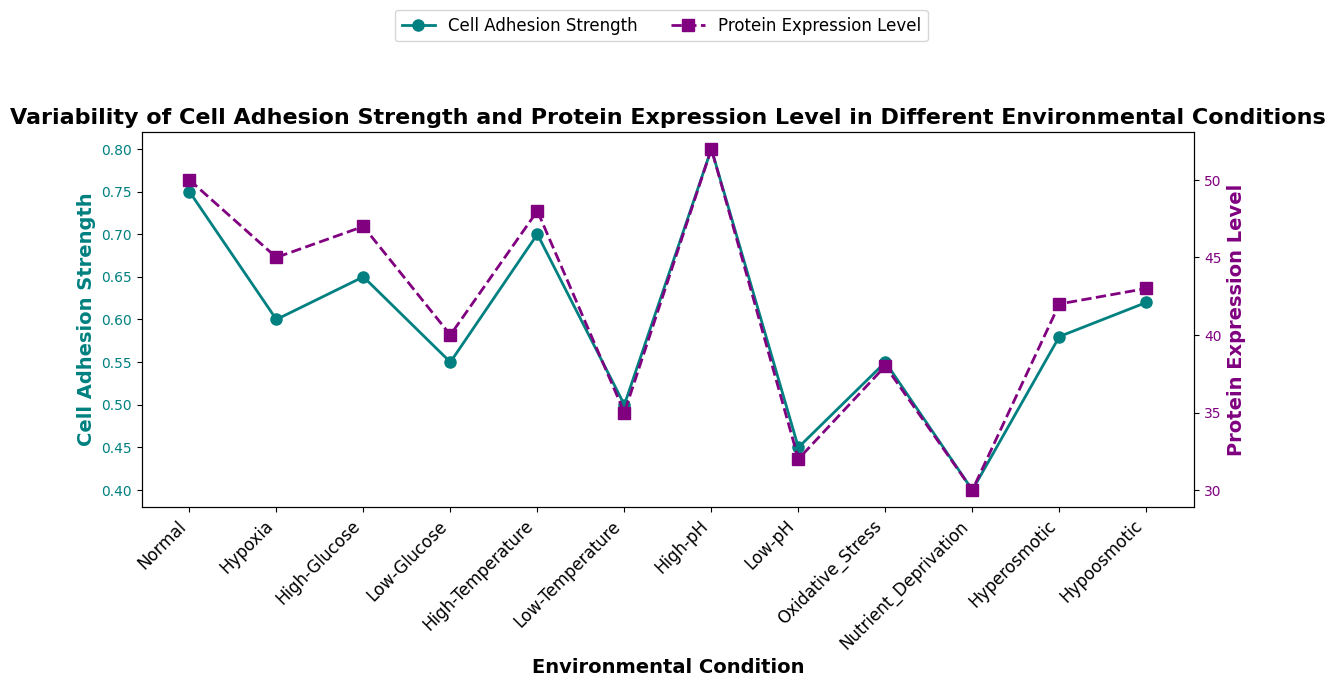What environmental condition shows the highest cell adhesion strength? By checking the plot, we can see that the highest point on the cell adhesion strength curve corresponds to the "High-pH" condition.
Answer: High-pH Which environmental condition has the lowest protein expression level? The graph shows the lowest point on the protein expression level curve, which corresponds to the "Nutrient Deprivation" condition.
Answer: Nutrient Deprivation Is there any condition where both cell adhesion strength and protein expression level are above their respective average values? First, calculate the average cell adhesion strength (sum all values and divide by the number of conditions: (0.75+0.60+0.65+0.55+0.70+0.50+0.80+0.45+0.55+0.40+0.58+0.62)/12 = 0.607) and protein expression level (sum all values and divide by the number of conditions: (50+45+47+40+48+35+52+32+38+30+42+43)/12 = 41.42). Then, find conditions where both values are above these averages. Only "High-pH" meets this criterion.
Answer: High-pH How does cell adhesion strength change under hypoosmotic vs. hyperosmotic conditions? Check the plot for the "Hypoosmotic" and "Hyperosmotic" conditions. Cell adhesion strength for "Hypoosmotic" is 0.62 and for "Hyperosmotic" is 0.58. Cell adhesion strength is higher under hypoosmotic conditions.
Answer: Higher under hypoosmotic What is the difference in cell adhesion strength between normal and nutrient deprivation conditions? Find the cell adhesion strength for "Normal" (0.75) and "Nutrient Deprivation" (0.40). Subtract the value for "Nutrient Deprivation" from the value for "Normal": 0.75 - 0.40 = 0.35.
Answer: 0.35 Does a higher protein expression level always correspond to a higher cell adhesion strength? Check the figure to match high protein expression level points with their respective cell adhesion strengths. For example, "Normal" has high values for both, but "Low-pH" with a low protein expression level of 32 has a low cell adhesion strength of 0.45, demonstrating it is not always correlated.
Answer: No On average, how do cell adhesion strengths under temperature deviations (high and low) compare with the rest of the conditions? Average cell adhesion strength for high and low temperature is (0.70 + 0.50)/2 = 0.60. Average for rest of the conditions is (0.75+0.60+0.65+0.55+0.80+0.45+0.55+0.40+0.58+0.62)/10 = 0.605. Compare these averages: 0.60 vs 0.605. The average is slightly lower for temperature deviations than other conditions.
Answer: Slightly lower What are the visual characteristics of the trend lines for cell adhesion strength and protein expression levels? Observe the plot where the cell adhesion strength is marked with a teal solid line with circular markers, and the protein expression level is marked with a purple dashed line with square markers.
Answer: Cell adhesion strength: teal, solid line, circular markers; Protein expression levels: purple, dashed line, square markers Which condition has the smallest difference in cell adhesion strength and protein expression level values? For each condition, subtract protein expression level from cell adhesion strength and find the minimum difference: 
 "Low-pH": 0.45 - 32 = -31.55, 
 "Hypoosmotic": 0.62 - 43 = -42.38, and so on. The condition with the smallest difference is "Normal" where the difference is 50 - 0.75 = -49.25, which is the smallest closer to zero compared to others.
Answer: Normal 